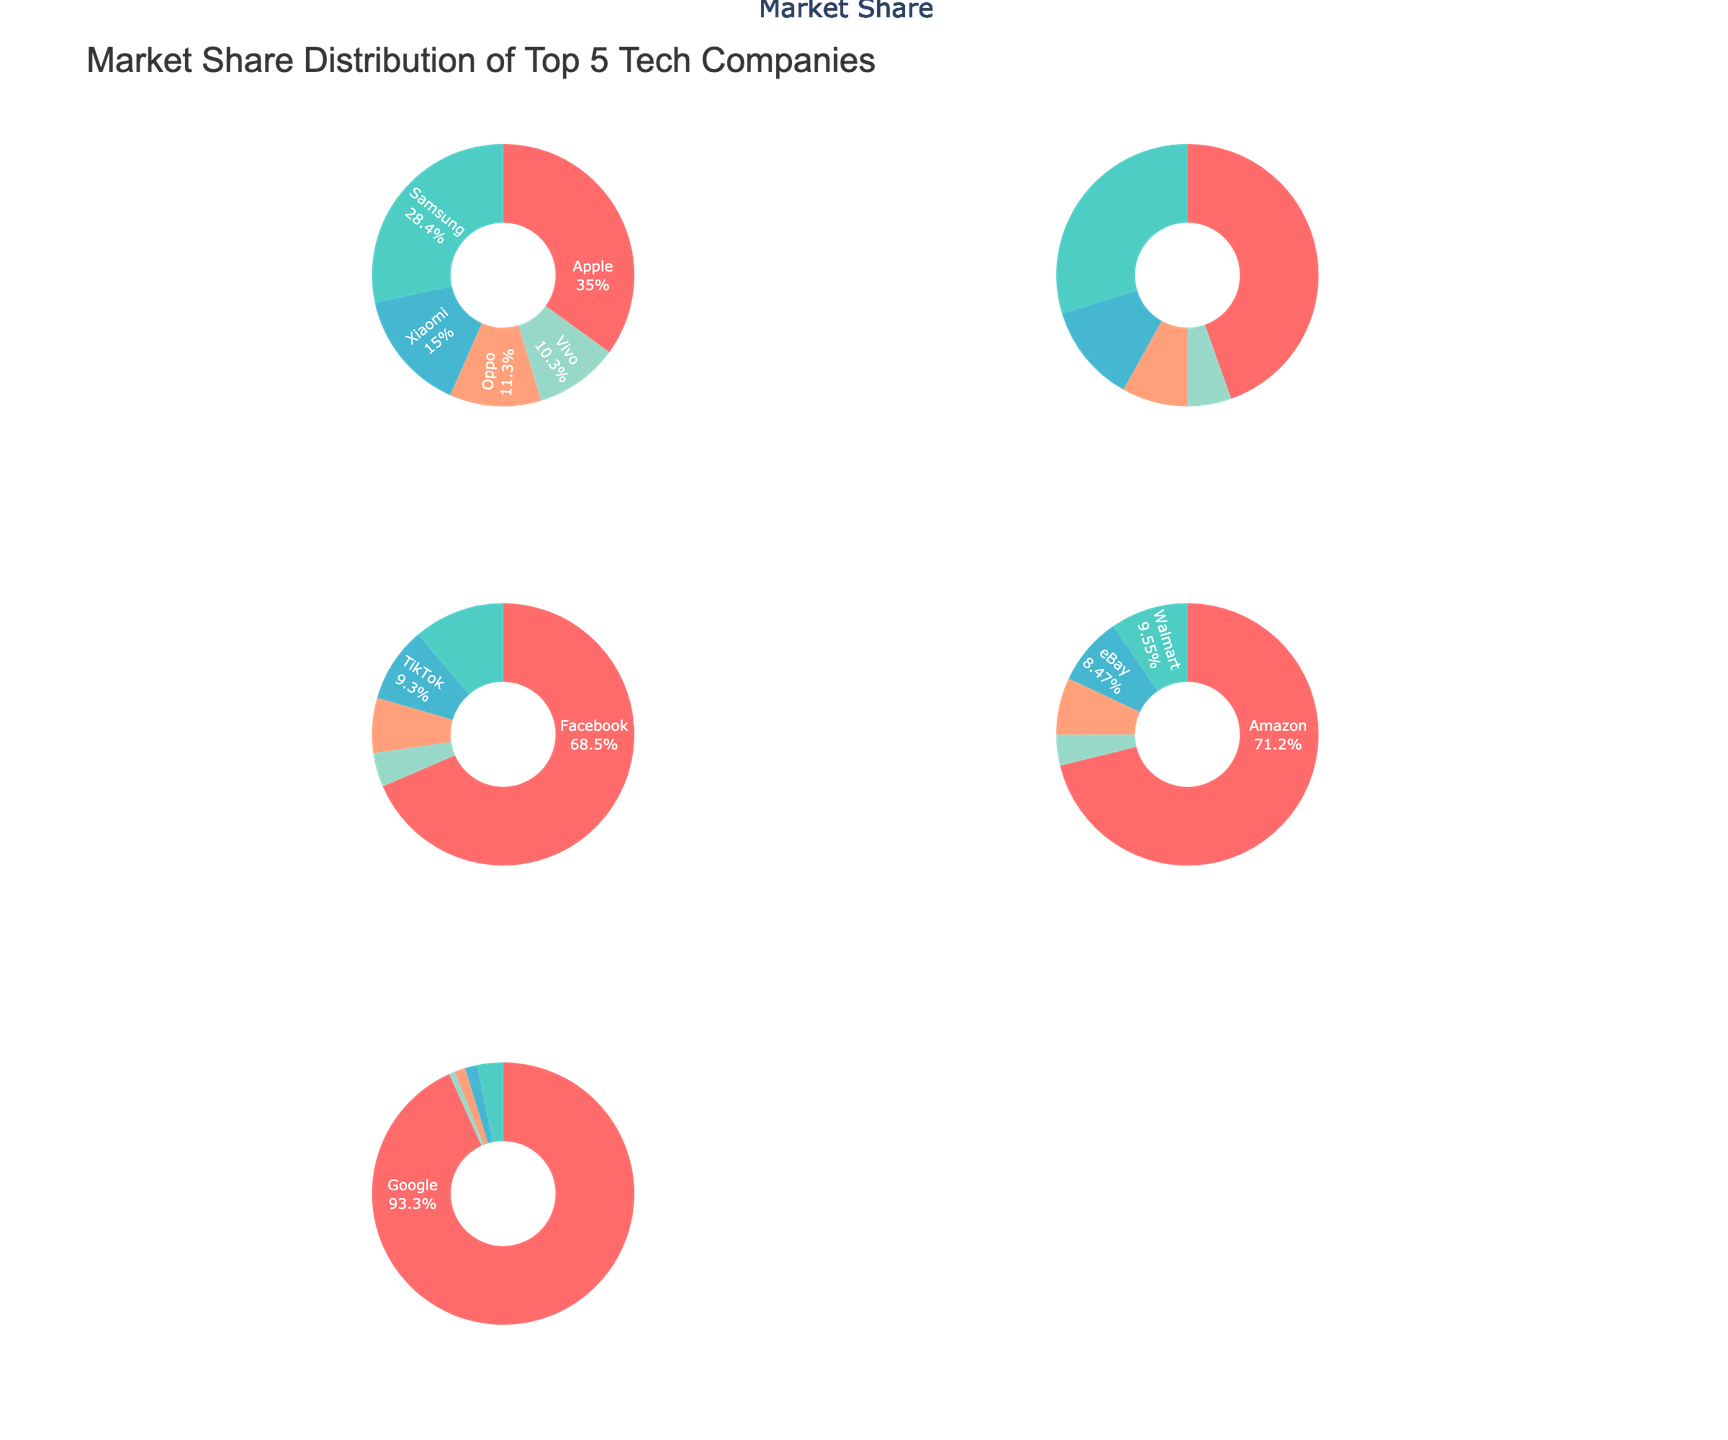What is the market share percentage of Amazon AWS in the Cloud Services category? The pie chart for the Cloud Services category shows the market share percentages for each company. Locate Amazon AWS in that section to find its market share.
Answer: 33% Which company holds the largest market share in the Social Media category? Look for the largest slice in the Social Media pie chart. The largest percentage visually dominates the pie chart, which corresponds to Facebook.
Answer: Facebook What is the combined market share of Samsung and Xiaomi in the Smartphones category? In the Smartphones pie chart, identify the market shares of Samsung (22.3%) and Xiaomi (11.8%). Add these two percentages together.
Answer: 34.1% Who has a higher market share in E-commerce, Amazon or Walmart? In the E-commerce pie chart, compare the slices labeled Amazon and Walmart. Amazon holds a significantly larger slice than Walmart.
Answer: Amazon Which category has the company with the highest individual market share, and which company is it? Review each pie chart to identify the company with the largest slice in any category. Google in the Search Engines category holds the highest individual market share at 91.4%.
Answer: Search Engines, Google What percentage of the market share does Apple have in the Smartphones and E-commerce categories combined? Identify Apple's market shares in both categories: 27.5% in Smartphones and 3.9% in E-commerce. Add these percentages together.
Answer: 31.4% Rank the top three companies in the Cloud Services category by market share. Examine the Cloud Services pie chart and list the top three slices by percentage: Amazon AWS, Microsoft Azure, and Google Cloud.
Answer: Amazon AWS, Microsoft Azure, Google Cloud Is there a company that appears in multiple categories? If yes, which one(s) and in which categories? Check across all the pie charts for repeated company names. Apple appears in both Smartphones and E-commerce categories.
Answer: Apple, Smartphones and E-commerce What is the smallest market share percentage displayed in the pie charts and which company does it represent? Identify the smallest slice in any pie chart. DuckDuckGo in the Search Engines category has the smallest market share at 0.7%.
Answer: DuckDuckGo, 0.7% How does Facebook's market share in Social Media compare to Google's in Search Engines? Compare the pie chart slices for Facebook in Social Media (68.5%) and Google in Search Engines (91.4%). Google holds a larger percentage.
Answer: Google has a larger market share than Facebook 